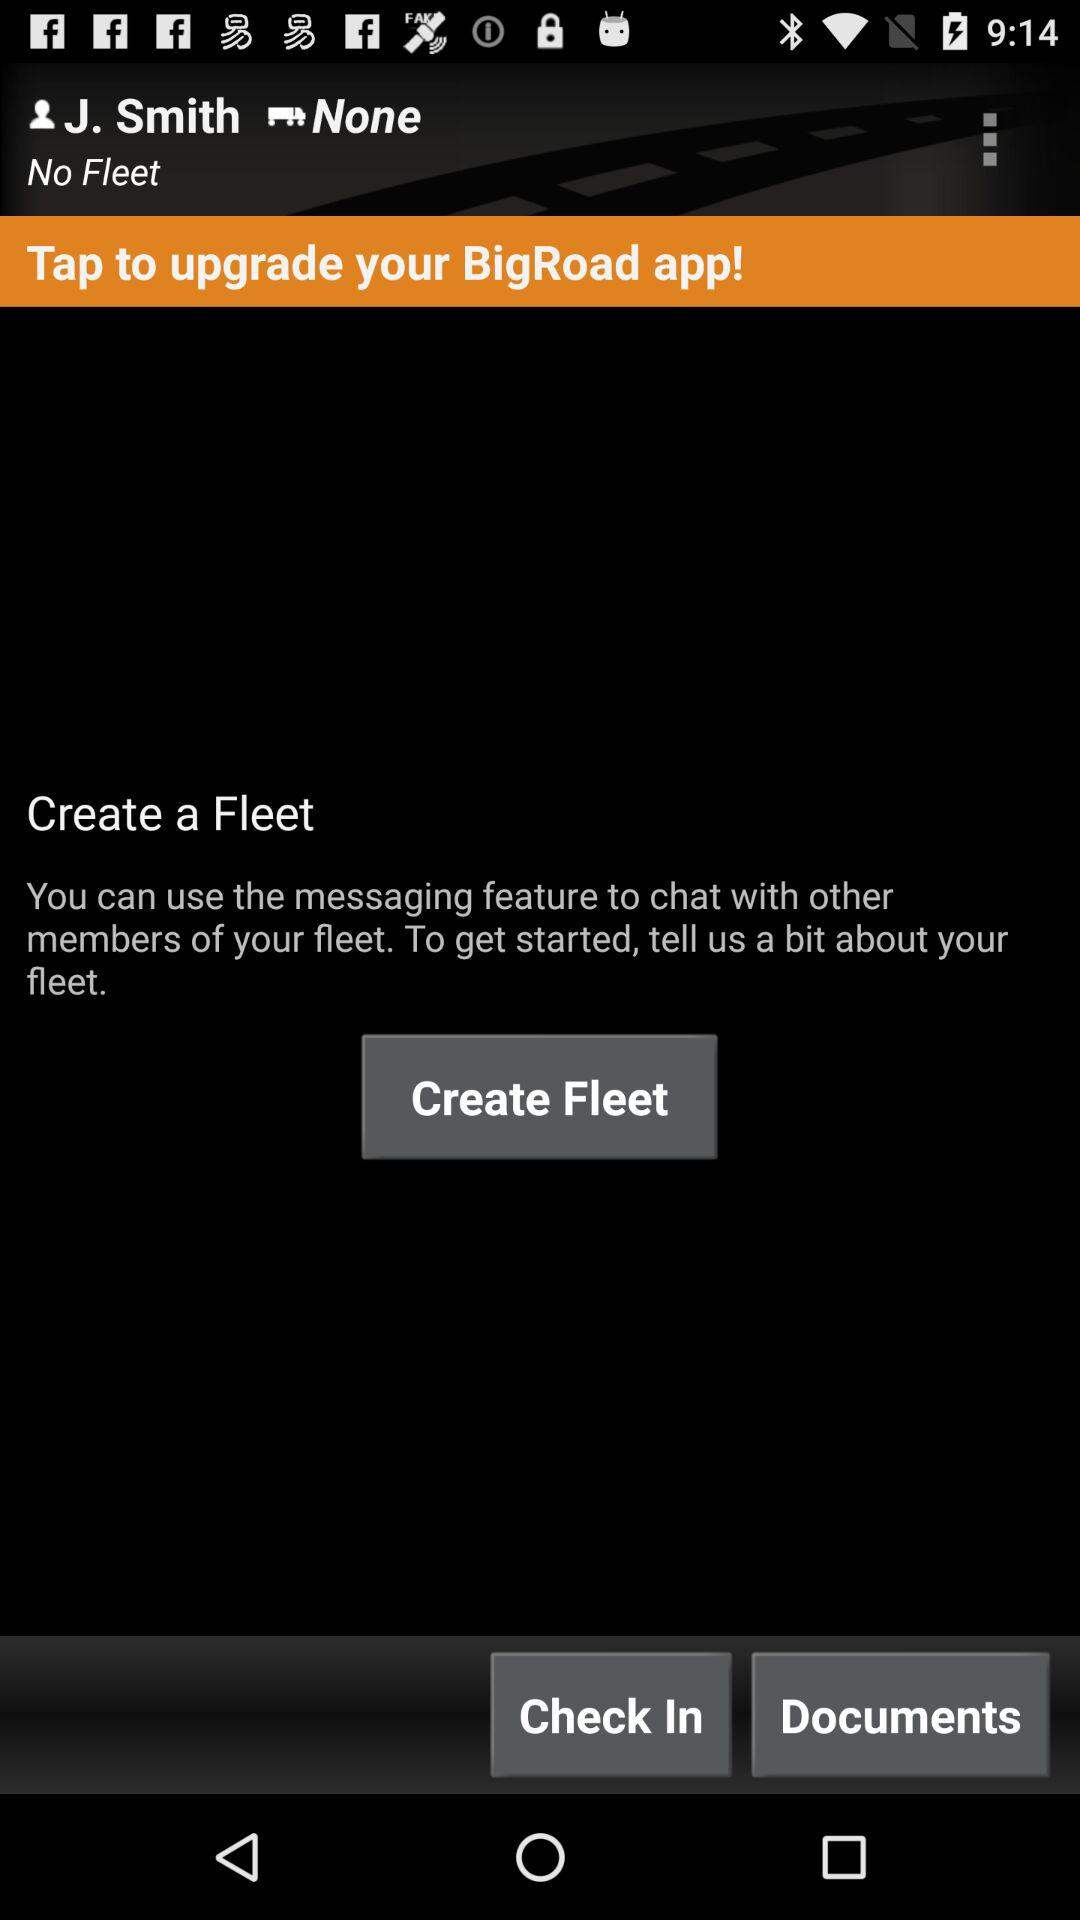What is the name of the profile? The name of the profile is J. Smith. 